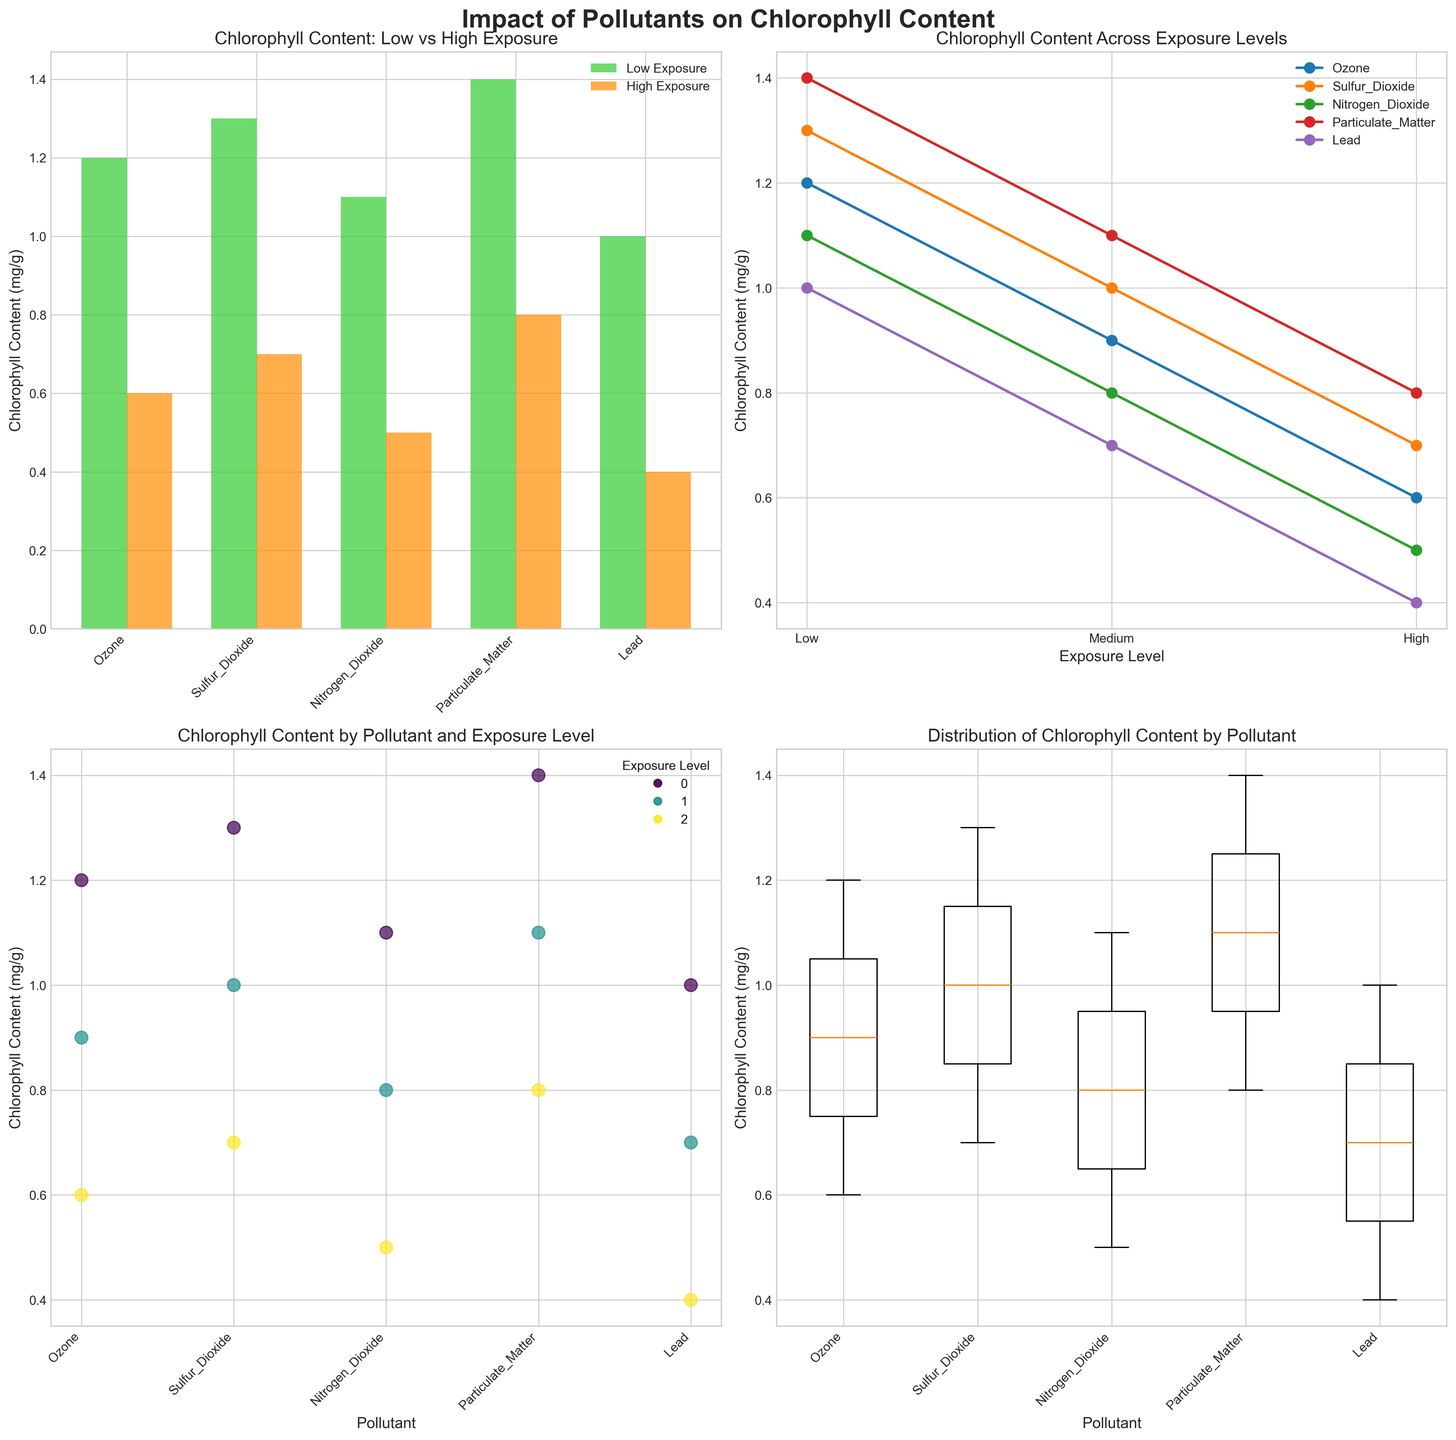What is the title of the subplot in the top-left corner? The top-left subplot shows a bar plot. The title is located at the top of the subplot.
Answer: Chlorophyll Content: Low vs High Exposure Which pollutant leads to the lowest chlorophyll content under high exposure levels? In the top-left bar plot, bars labeled "High Exposure" show chlorophyll content for high exposure levels. By comparing these bars, the pollutant with the smallest bar is identified.
Answer: Lead Based on the line plot, which pollutant shows the steepest decline in chlorophyll content as exposure levels increase? In the top-right line plot, examine the lines' slopes as they progress from Low to High exposure levels. The pollutant with the line having the steepest decline will show the fastest decrease.
Answer: Nitrogen Dioxide What color represents low exposure in the scatter plot? The scatter plot in the bottom-left corner uses different colors to represent exposure levels. According to the legend, identify the color associated with "Low".
Answer: Limegreen For which pollutant does low exposure have the highest chlorophyll content? On the bottom-right box plot, boxes represent different pollutants, and each box plot shows a distribution where the top whisker indicates the highest value under low exposure. Identify the box with the highest top whisker.
Answer: Particulate Matter Which subplots contain legends? Review the figure and identify which plots include a legend that explains the markers or lines used in the plots.
Answer: Top-left, Top-right, Bottom-left How does the chlorophyll content for Oak trees change with increasing exposure to sulfur dioxide? In the top-right line plot, find the line associated with Sulfur Dioxide and observe how the chlorophyll content values change from Low to High exposure.
Answer: Decreases Compare the chlorophyll content for low and high exposure of ozone. How much more or less is the chlorophyll content under low exposure? In the top-left bar plot, compare the "Low Exposure" and "High Exposure" bars for ozone. Calculate the difference by subtracting the high exposure value from the low exposure value.
Answer: 0.6 mg/g more Which plot shows the overall variation in chlorophyll content for each pollutant? Examine the different types of plots and identify which one displays the entire range of values (variation) of chlorophyll content for each pollutant.
Answer: Bottom-right Box plot Which subplot shows detailed values for each species and their response to pollutants? Evaluate which plot provides information involving specific data points and their associated response rather than summarizing or aggregating results.
Answer: Bottom-left Scatter plot 